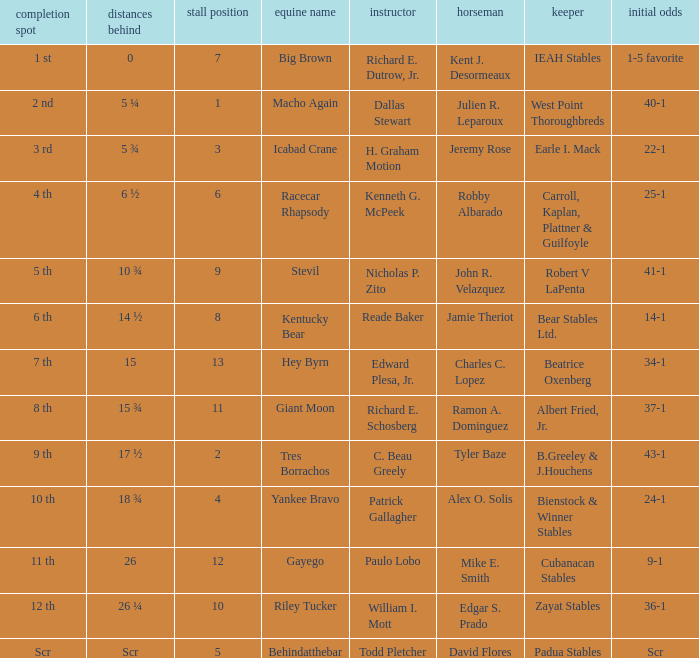What is the lengths behind of Jeremy Rose? 5 ¾. 